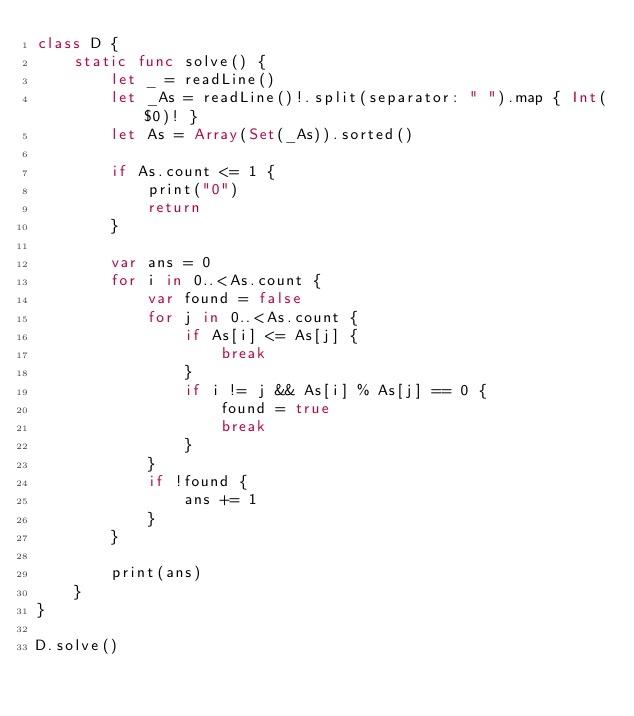Convert code to text. <code><loc_0><loc_0><loc_500><loc_500><_Swift_>class D {
    static func solve() {
        let _ = readLine()
        let _As = readLine()!.split(separator: " ").map { Int($0)! }
        let As = Array(Set(_As)).sorted()

        if As.count <= 1 {
            print("0")
            return
        }

        var ans = 0
        for i in 0..<As.count {
            var found = false
            for j in 0..<As.count {
                if As[i] <= As[j] {
                    break
                }
                if i != j && As[i] % As[j] == 0 {
                    found = true
                    break
                }
            }
            if !found {
                ans += 1
            }
        }

        print(ans)
    }
}

D.solve()
</code> 